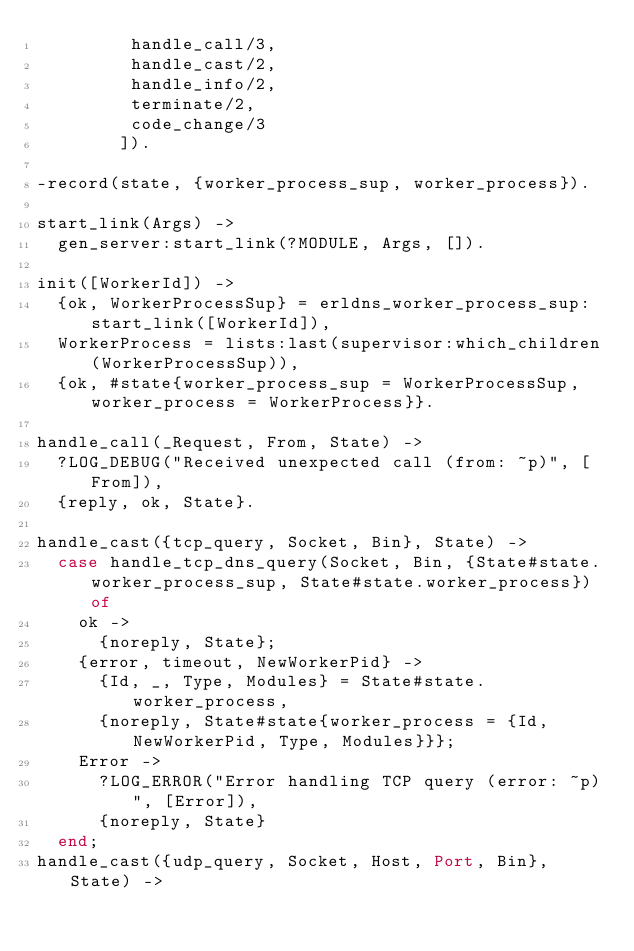Convert code to text. <code><loc_0><loc_0><loc_500><loc_500><_Erlang_>         handle_call/3,
         handle_cast/2,
         handle_info/2,
         terminate/2,
         code_change/3
        ]).

-record(state, {worker_process_sup, worker_process}).

start_link(Args) ->
  gen_server:start_link(?MODULE, Args, []).

init([WorkerId]) ->
  {ok, WorkerProcessSup} = erldns_worker_process_sup:start_link([WorkerId]),
  WorkerProcess = lists:last(supervisor:which_children(WorkerProcessSup)),
  {ok, #state{worker_process_sup = WorkerProcessSup, worker_process = WorkerProcess}}.

handle_call(_Request, From, State) ->
  ?LOG_DEBUG("Received unexpected call (from: ~p)", [From]),
  {reply, ok, State}.

handle_cast({tcp_query, Socket, Bin}, State) ->
  case handle_tcp_dns_query(Socket, Bin, {State#state.worker_process_sup, State#state.worker_process}) of
    ok ->
      {noreply, State};
    {error, timeout, NewWorkerPid} ->
      {Id, _, Type, Modules} = State#state.worker_process,
      {noreply, State#state{worker_process = {Id, NewWorkerPid, Type, Modules}}};
    Error ->
      ?LOG_ERROR("Error handling TCP query (error: ~p)", [Error]),
      {noreply, State}
  end;
handle_cast({udp_query, Socket, Host, Port, Bin}, State) -></code> 